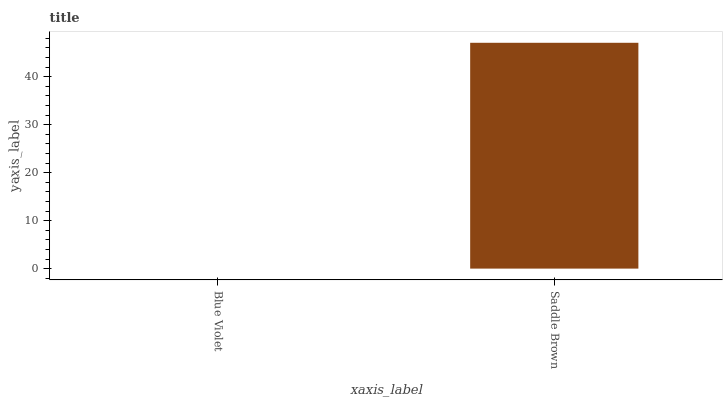Is Blue Violet the minimum?
Answer yes or no. Yes. Is Saddle Brown the maximum?
Answer yes or no. Yes. Is Saddle Brown the minimum?
Answer yes or no. No. Is Saddle Brown greater than Blue Violet?
Answer yes or no. Yes. Is Blue Violet less than Saddle Brown?
Answer yes or no. Yes. Is Blue Violet greater than Saddle Brown?
Answer yes or no. No. Is Saddle Brown less than Blue Violet?
Answer yes or no. No. Is Saddle Brown the high median?
Answer yes or no. Yes. Is Blue Violet the low median?
Answer yes or no. Yes. Is Blue Violet the high median?
Answer yes or no. No. Is Saddle Brown the low median?
Answer yes or no. No. 